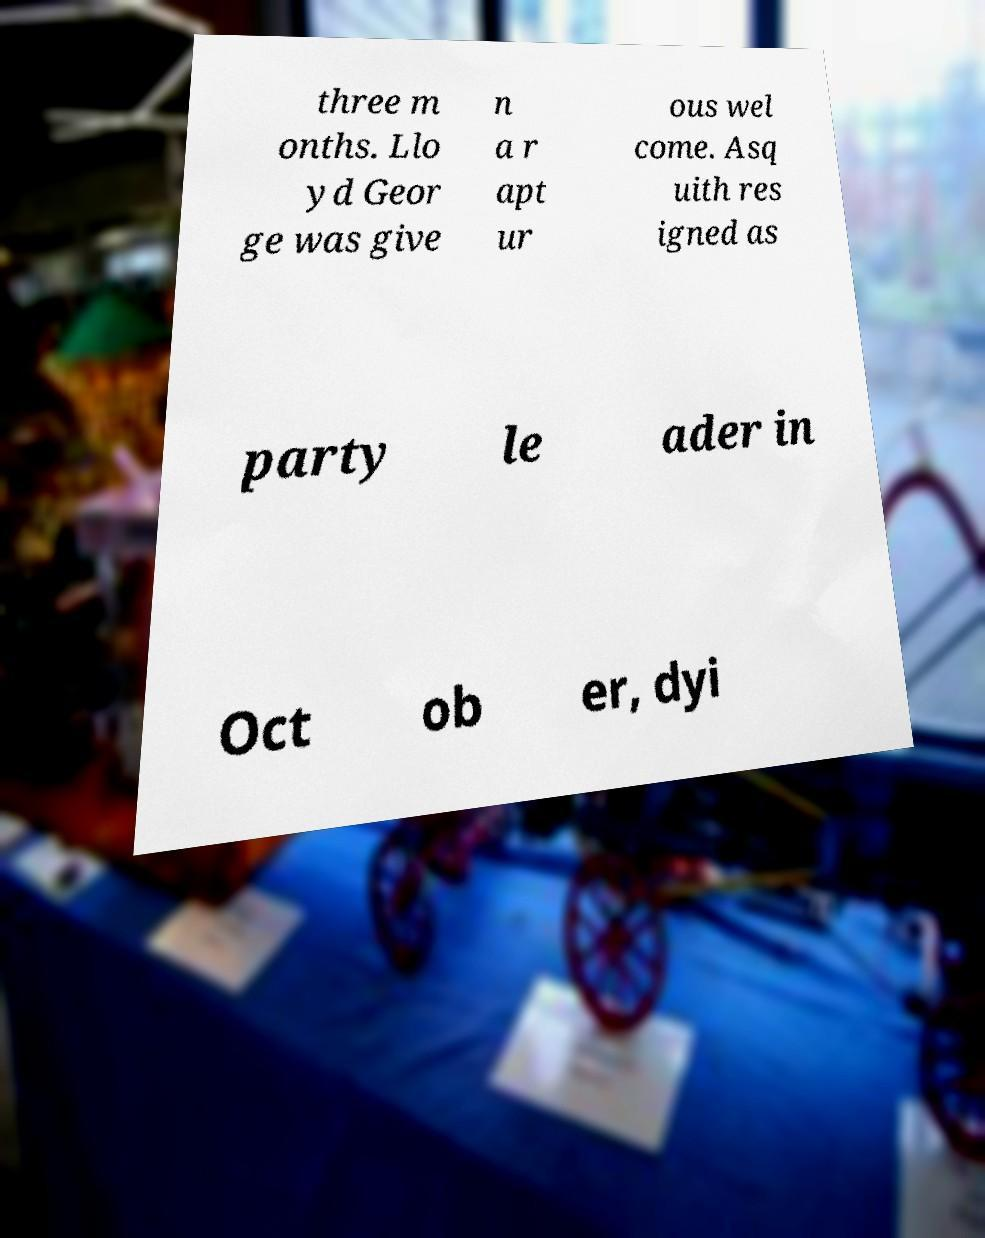Can you accurately transcribe the text from the provided image for me? three m onths. Llo yd Geor ge was give n a r apt ur ous wel come. Asq uith res igned as party le ader in Oct ob er, dyi 